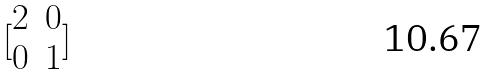Convert formula to latex. <formula><loc_0><loc_0><loc_500><loc_500>[ \begin{matrix} 2 & 0 \\ 0 & 1 \end{matrix} ]</formula> 